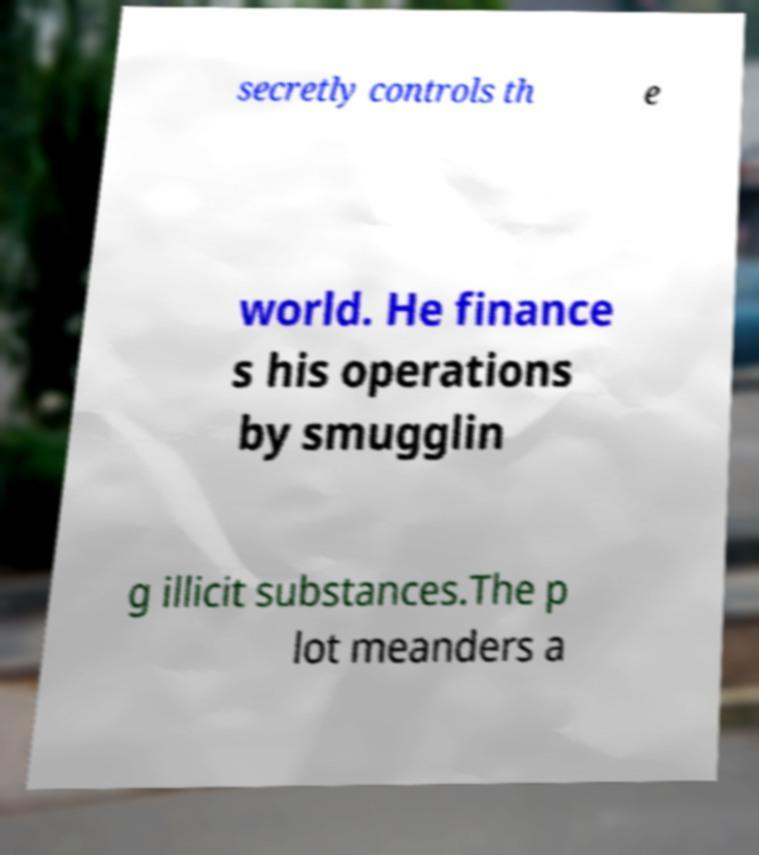I need the written content from this picture converted into text. Can you do that? secretly controls th e world. He finance s his operations by smugglin g illicit substances.The p lot meanders a 